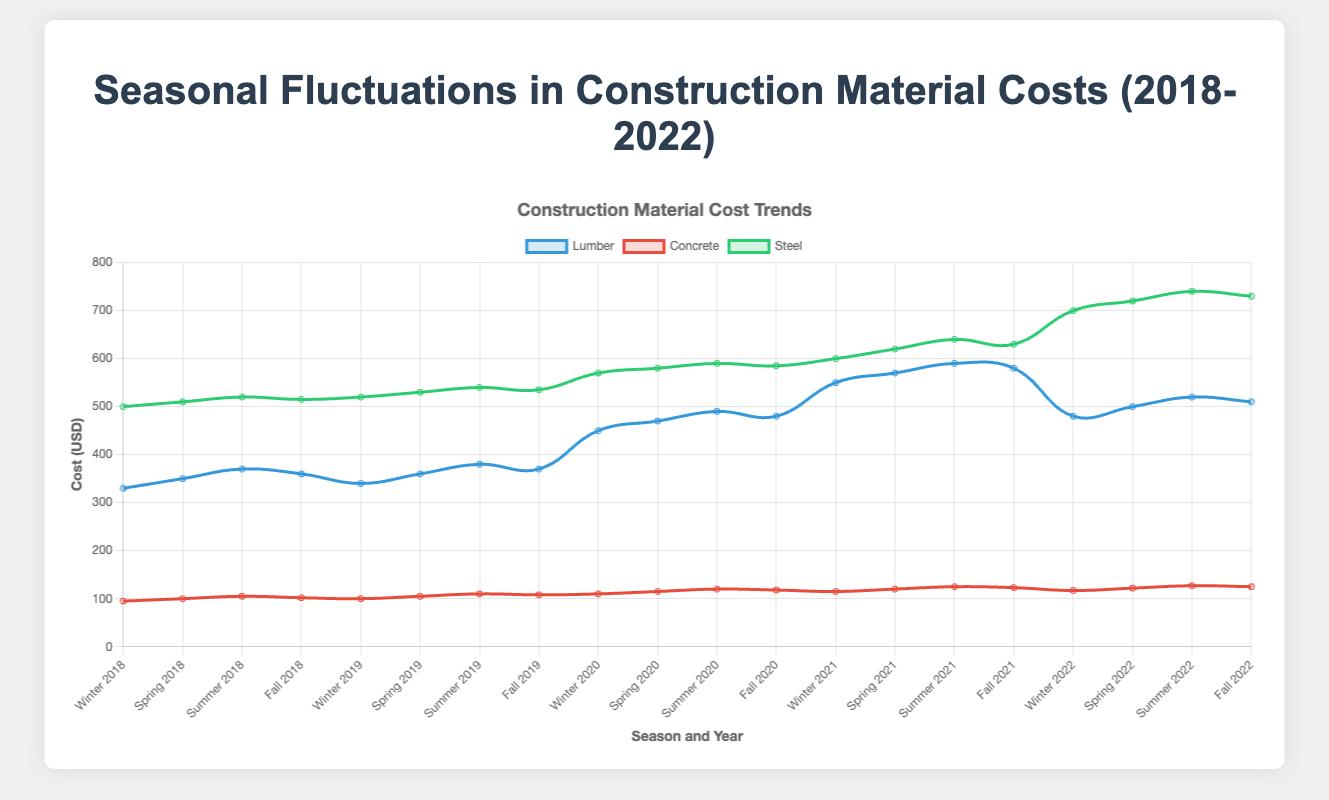Which material had the highest cost in Winter 2022? The plot indicates that Steel had the highest cost among all materials in Winter 2022. According to the plot, Steel's cost was significantly higher compared to Lumber and Concrete.
Answer: Steel During 2020, in which season did Lumber experience its highest cost? From the plot, Lumber reached its highest cost in the Summer of 2020. The cost in Summer 2020 was higher than in Winter, Spring, or Fall of the same year.
Answer: Summer How did the cost of Concrete in Fall 2018 compare to that in Fall 2022? Referring to the figure, Concrete's cost in Fall 2018 was approximately 102 USD, while in Fall 2022, it was around 125 USD. This indicates that the cost of Concrete increased over this period.
Answer: Increased What is the average cost of Steel over all seasons in 2021? First, find the costs of Steel for each season in 2021, which are Winter: 600, Spring: 620, Summer: 640, and Fall: 630. The sum of these costs is 2490. To find the average, divide 2490 by 4, the number of seasons. 2490 / 4 = 622.5.
Answer: 622.5 Identify a year in which Lumber's cost saw a notable drop in Winter compared to the previous Fall. In Winter 2022, Lumber's cost dropped to 480 from 580 in Fall 2021, indicating a significant drop compared to the previous season's cost.
Answer: 2022 Which material had the least fluctuation in prices across all seasons in 2019? By observing the range of costs for each material in 2019, we see that Concrete exhibits the smallest fluctuation. Its costs range from 100 in Winter to 110 in Summer, indicating a minimal change of only 10 USD.
Answer: Concrete How did the cost trend for Lumber in 2020 compare to Steel in the same year across all seasons? Examining the trend lines, both Lumber and Steel experienced an increase in costs across all seasons in 2020. However, the general upward trend for Lumber was less pronounced compared to Steel, which saw a more significant increase.
Answer: Similar but less pronounced for Lumber What is the percentage increase in the cost of Lumber from Winter 2018 to Winter 2021? The cost of Lumber in Winter 2018 was 330 USD, and in Winter 2021 it was 550 USD. The increase is 550 - 330 = 220 USD. The percentage increase is (220 / 330) * 100 ≈ 66.67%.
Answer: 66.67% Which material had the highest relative increase from Winter to Summer in 2018? By comparing the increase in costs from Winter to Summer in 2018 for each material, we see that Steel went from 500 to 520, an increase of 20; Concrete from 95 to 105, an increase of 10; and Lumber from 330 to 370, an increase of 40. Relative to their initial Winter values, Lumber had the highest relative increase.
Answer: Lumber If a project required a consistent material cost year-round, which material would you recommend based on the 2022 data? Observing the 2022 data, Concrete maintained the most stable prices across all seasons (ranging from 117 to 127), making it the best choice for a project needing consistent costs.
Answer: Concrete 